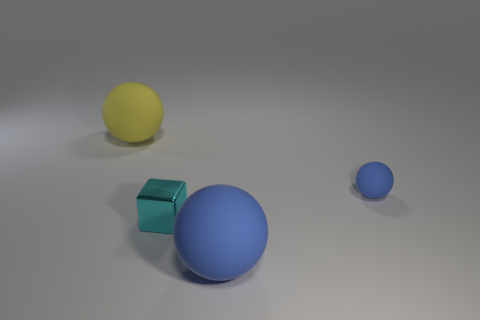Does the blue object that is in front of the small cyan block have the same material as the cyan block?
Your response must be concise. No. How many things are either cyan things that are on the left side of the tiny blue sphere or tiny green metallic cylinders?
Keep it short and to the point. 1. Are there more large things that are in front of the tiny cyan metallic thing than tiny blue spheres behind the small matte object?
Make the answer very short. Yes. Is the size of the cyan metallic thing the same as the blue thing behind the big blue sphere?
Give a very brief answer. Yes. What number of blocks are either tiny metal objects or big purple rubber things?
Keep it short and to the point. 1. What size is the other blue ball that is the same material as the big blue ball?
Give a very brief answer. Small. Do the blue matte ball behind the small cyan shiny object and the blue matte sphere to the left of the small blue ball have the same size?
Provide a short and direct response. No. How many things are blue balls or large yellow matte balls?
Your answer should be very brief. 3. The large yellow object has what shape?
Offer a terse response. Sphere. What is the size of the other blue object that is the same shape as the big blue thing?
Your answer should be very brief. Small. 